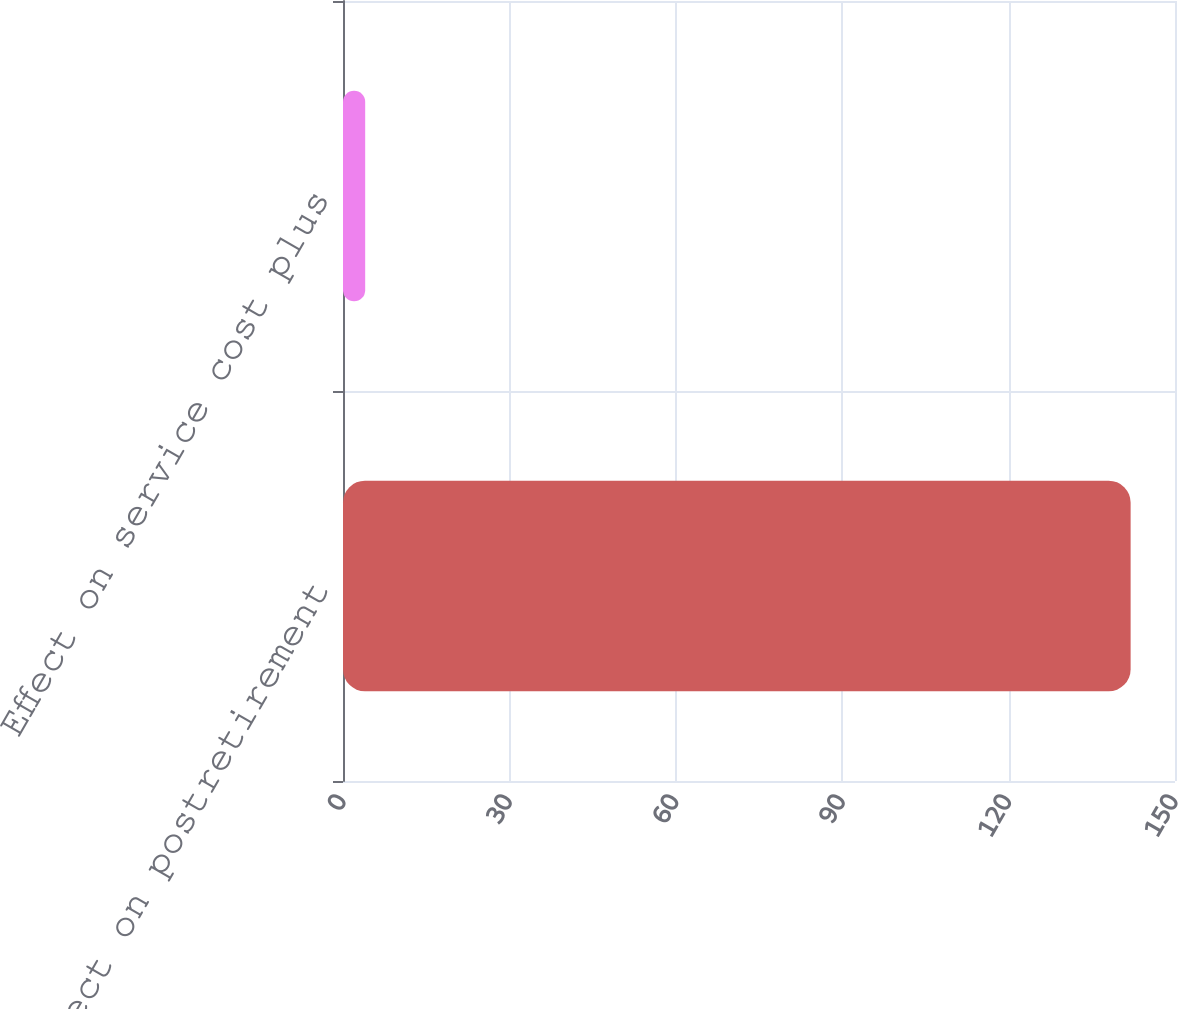Convert chart to OTSL. <chart><loc_0><loc_0><loc_500><loc_500><bar_chart><fcel>Effect on postretirement<fcel>Effect on service cost plus<nl><fcel>142<fcel>4<nl></chart> 